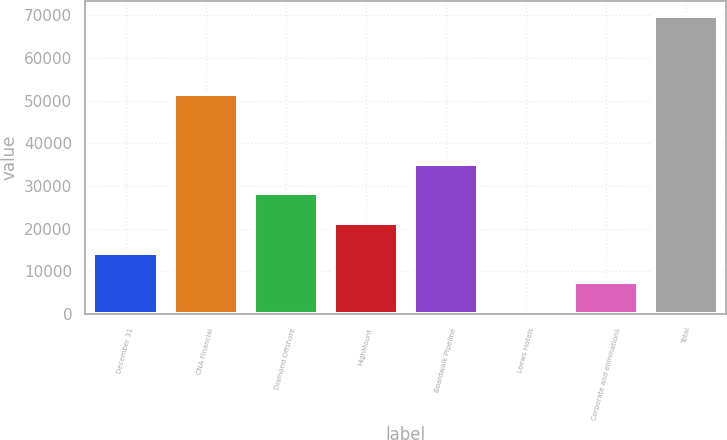Convert chart to OTSL. <chart><loc_0><loc_0><loc_500><loc_500><bar_chart><fcel>December 31<fcel>CNA Financial<fcel>Diamond Offshore<fcel>HighMount<fcel>Boardwalk Pipeline<fcel>Loews Hotels<fcel>Corporate and eliminations<fcel>Total<nl><fcel>14368.2<fcel>51624<fcel>28240.4<fcel>21304.3<fcel>35176.5<fcel>496<fcel>7432.1<fcel>69857<nl></chart> 